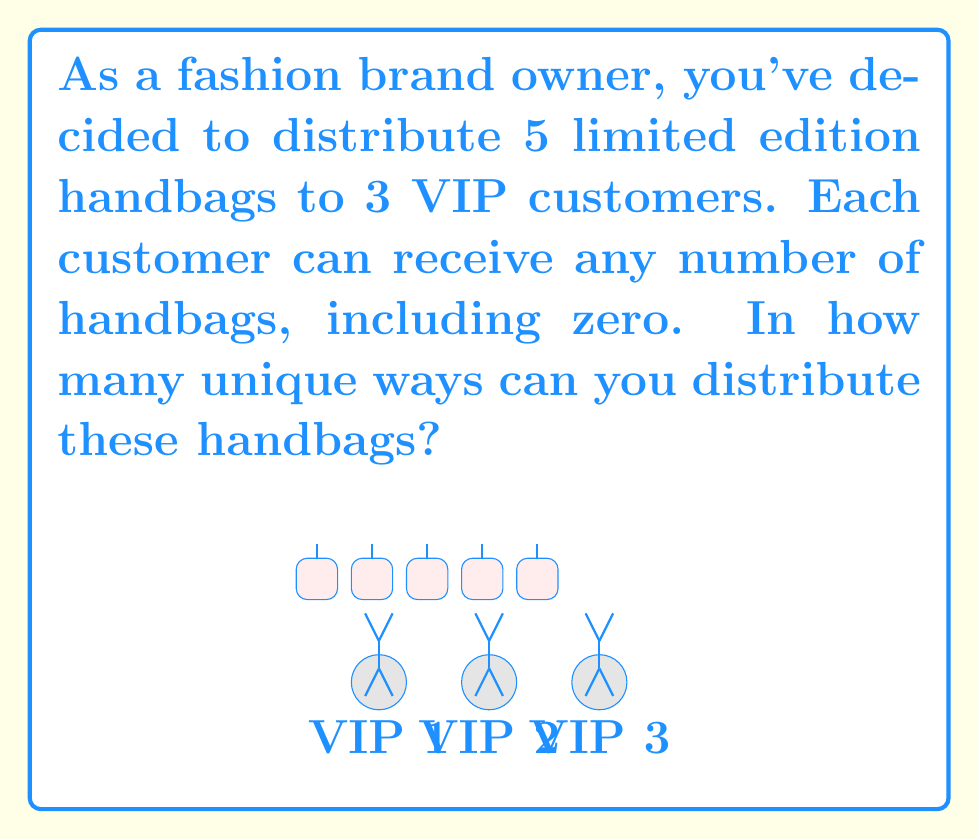Give your solution to this math problem. This problem can be solved using the concept of stars and bars in combinatorics. Here's how:

1) We need to distribute 5 identical handbags among 3 VIP customers. This is equivalent to placing 5 stars (representing handbags) into 3 groups (representing customers).

2) In the stars and bars method, we use bars to separate the groups. We need 2 bars to create 3 groups.

3) So, we have 5 stars and 2 bars, making a total of 7 objects to arrange.

4) The question then becomes: in how many ways can we arrange 5 stars and 2 bars?

5) This is a combination problem. We need to choose the positions for either the stars or the bars out of the 7 total positions.

6) Let's choose the positions for the 2 bars. This can be represented as:

   $$\binom{7}{2}$$

7) We can calculate this using the combination formula:

   $$\binom{7}{2} = \frac{7!}{2!(7-2)!} = \frac{7!}{2!(5)!}$$

8) Expanding this:
   
   $$\frac{7 * 6 * 5!}{2 * 1 * 5!} = \frac{42}{2} = 21$$

Therefore, there are 21 unique ways to distribute the handbags.
Answer: 21 